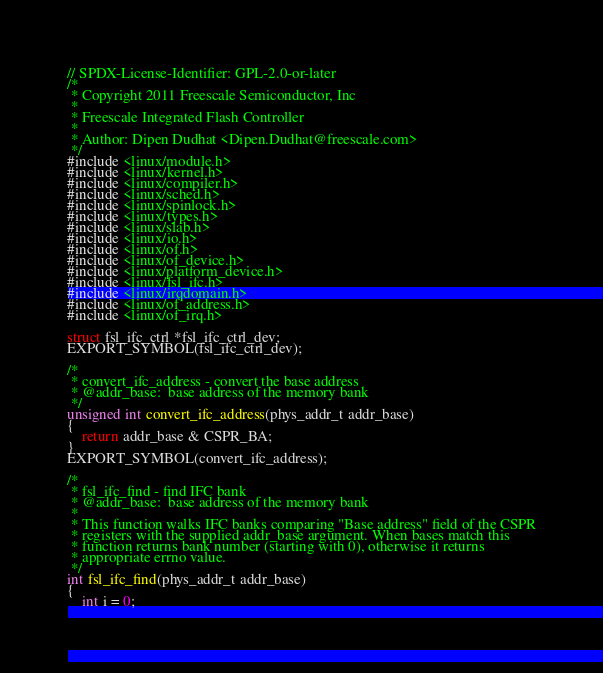<code> <loc_0><loc_0><loc_500><loc_500><_C_>// SPDX-License-Identifier: GPL-2.0-or-later
/*
 * Copyright 2011 Freescale Semiconductor, Inc
 *
 * Freescale Integrated Flash Controller
 *
 * Author: Dipen Dudhat <Dipen.Dudhat@freescale.com>
 */
#include <linux/module.h>
#include <linux/kernel.h>
#include <linux/compiler.h>
#include <linux/sched.h>
#include <linux/spinlock.h>
#include <linux/types.h>
#include <linux/slab.h>
#include <linux/io.h>
#include <linux/of.h>
#include <linux/of_device.h>
#include <linux/platform_device.h>
#include <linux/fsl_ifc.h>
#include <linux/irqdomain.h>
#include <linux/of_address.h>
#include <linux/of_irq.h>

struct fsl_ifc_ctrl *fsl_ifc_ctrl_dev;
EXPORT_SYMBOL(fsl_ifc_ctrl_dev);

/*
 * convert_ifc_address - convert the base address
 * @addr_base:	base address of the memory bank
 */
unsigned int convert_ifc_address(phys_addr_t addr_base)
{
	return addr_base & CSPR_BA;
}
EXPORT_SYMBOL(convert_ifc_address);

/*
 * fsl_ifc_find - find IFC bank
 * @addr_base:	base address of the memory bank
 *
 * This function walks IFC banks comparing "Base address" field of the CSPR
 * registers with the supplied addr_base argument. When bases match this
 * function returns bank number (starting with 0), otherwise it returns
 * appropriate errno value.
 */
int fsl_ifc_find(phys_addr_t addr_base)
{
	int i = 0;
</code> 